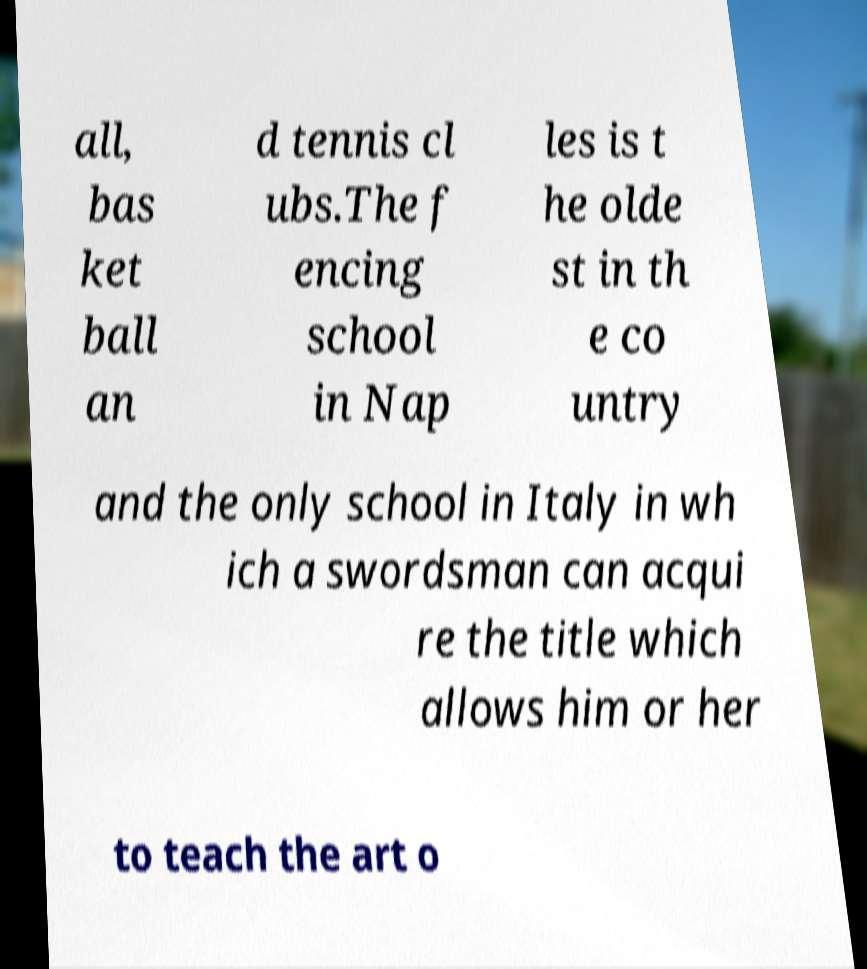Could you assist in decoding the text presented in this image and type it out clearly? all, bas ket ball an d tennis cl ubs.The f encing school in Nap les is t he olde st in th e co untry and the only school in Italy in wh ich a swordsman can acqui re the title which allows him or her to teach the art o 